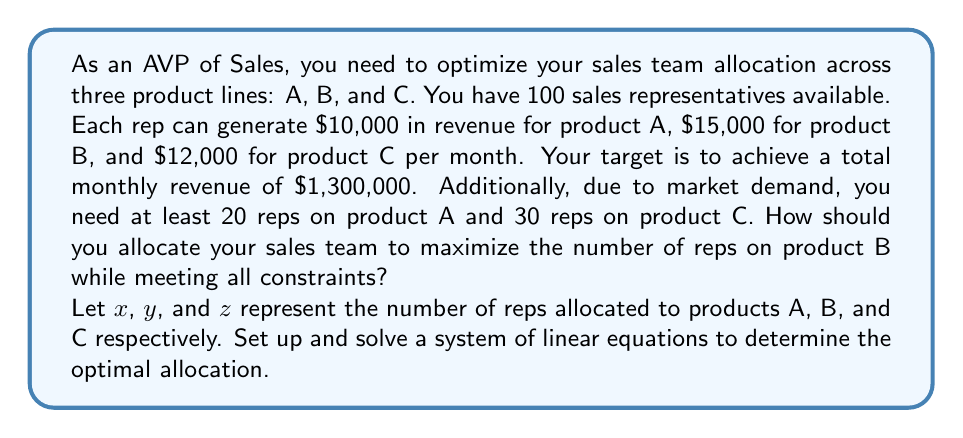Can you solve this math problem? Let's approach this step-by-step:

1) First, we set up our constraints:

   Total reps: $x + y + z = 100$ (Equation 1)
   Revenue target: $10000x + 15000y + 12000z = 1300000$ (Equation 2)
   Minimum reps for A: $x \geq 20$
   Minimum reps for C: $z \geq 30$

2) We want to maximize $y$, so we'll use the minimum values for $x$ and $z$:
   $x = 20$ and $z = 30$

3) Substituting these into Equation 1:
   $20 + y + 30 = 100$
   $y = 50$

4) Now, let's check if this satisfies Equation 2:
   $10000(20) + 15000y + 12000(30) = 1300000$
   $200000 + 15000y + 360000 = 1300000$
   $15000y = 740000$
   $y = 49.33$

5) Since $y$ must be an integer, we need to adjust our allocation. We'll decrease $y$ to 49 and increase $x$ or $z$.

6) Let's try increasing $x$ to 21:
   $10000(21) + 15000(49) + 12000(30) = 1300000$
   $210000 + 735000 + 360000 = 1305000$

7) This exceeds our target slightly, so it's a valid solution that maximizes $y$ while meeting all constraints.
Answer: Optimal allocation: 21 reps for product A, 49 reps for product B, 30 reps for product C. 